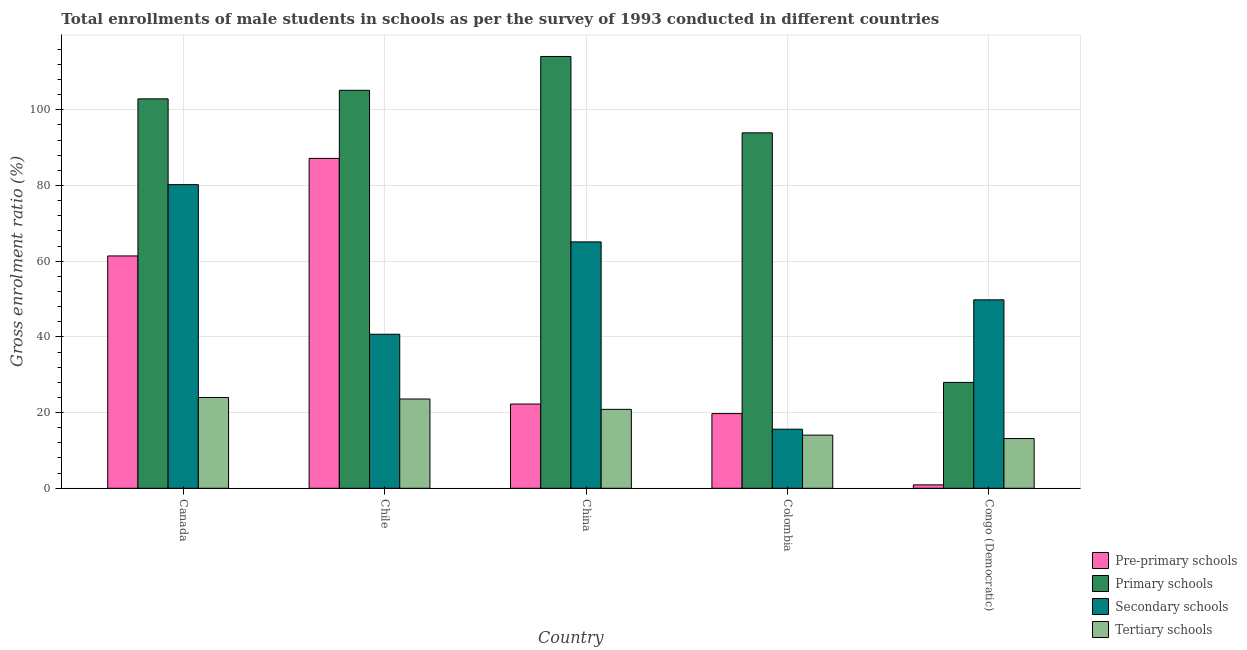How many different coloured bars are there?
Keep it short and to the point. 4. How many groups of bars are there?
Your answer should be compact. 5. Are the number of bars per tick equal to the number of legend labels?
Provide a succinct answer. Yes. Are the number of bars on each tick of the X-axis equal?
Offer a very short reply. Yes. How many bars are there on the 3rd tick from the right?
Provide a short and direct response. 4. What is the gross enrolment ratio(male) in pre-primary schools in Colombia?
Your answer should be very brief. 19.73. Across all countries, what is the maximum gross enrolment ratio(male) in primary schools?
Provide a short and direct response. 114.07. Across all countries, what is the minimum gross enrolment ratio(male) in primary schools?
Provide a succinct answer. 27.97. In which country was the gross enrolment ratio(male) in tertiary schools maximum?
Offer a terse response. Canada. In which country was the gross enrolment ratio(male) in secondary schools minimum?
Give a very brief answer. Colombia. What is the total gross enrolment ratio(male) in secondary schools in the graph?
Ensure brevity in your answer.  251.39. What is the difference between the gross enrolment ratio(male) in pre-primary schools in Colombia and that in Congo (Democratic)?
Provide a short and direct response. 18.83. What is the difference between the gross enrolment ratio(male) in tertiary schools in Canada and the gross enrolment ratio(male) in primary schools in Colombia?
Offer a terse response. -69.91. What is the average gross enrolment ratio(male) in tertiary schools per country?
Your response must be concise. 19.12. What is the difference between the gross enrolment ratio(male) in secondary schools and gross enrolment ratio(male) in tertiary schools in Chile?
Keep it short and to the point. 17.11. In how many countries, is the gross enrolment ratio(male) in secondary schools greater than 84 %?
Your response must be concise. 0. What is the ratio of the gross enrolment ratio(male) in pre-primary schools in China to that in Colombia?
Offer a very short reply. 1.13. Is the gross enrolment ratio(male) in secondary schools in Canada less than that in Congo (Democratic)?
Your answer should be compact. No. What is the difference between the highest and the second highest gross enrolment ratio(male) in primary schools?
Your answer should be very brief. 8.94. What is the difference between the highest and the lowest gross enrolment ratio(male) in pre-primary schools?
Your response must be concise. 86.24. What does the 4th bar from the left in Congo (Democratic) represents?
Offer a terse response. Tertiary schools. What does the 4th bar from the right in Colombia represents?
Ensure brevity in your answer.  Pre-primary schools. Is it the case that in every country, the sum of the gross enrolment ratio(male) in pre-primary schools and gross enrolment ratio(male) in primary schools is greater than the gross enrolment ratio(male) in secondary schools?
Keep it short and to the point. No. How many countries are there in the graph?
Provide a succinct answer. 5. What is the difference between two consecutive major ticks on the Y-axis?
Offer a terse response. 20. Does the graph contain any zero values?
Make the answer very short. No. What is the title of the graph?
Your response must be concise. Total enrollments of male students in schools as per the survey of 1993 conducted in different countries. Does "Rule based governance" appear as one of the legend labels in the graph?
Keep it short and to the point. No. What is the label or title of the X-axis?
Offer a very short reply. Country. What is the label or title of the Y-axis?
Give a very brief answer. Gross enrolment ratio (%). What is the Gross enrolment ratio (%) of Pre-primary schools in Canada?
Provide a succinct answer. 61.38. What is the Gross enrolment ratio (%) in Primary schools in Canada?
Offer a terse response. 102.87. What is the Gross enrolment ratio (%) of Secondary schools in Canada?
Provide a succinct answer. 80.21. What is the Gross enrolment ratio (%) in Tertiary schools in Canada?
Give a very brief answer. 23.98. What is the Gross enrolment ratio (%) in Pre-primary schools in Chile?
Your answer should be very brief. 87.14. What is the Gross enrolment ratio (%) in Primary schools in Chile?
Give a very brief answer. 105.13. What is the Gross enrolment ratio (%) of Secondary schools in Chile?
Offer a terse response. 40.69. What is the Gross enrolment ratio (%) of Tertiary schools in Chile?
Ensure brevity in your answer.  23.58. What is the Gross enrolment ratio (%) of Pre-primary schools in China?
Your response must be concise. 22.25. What is the Gross enrolment ratio (%) in Primary schools in China?
Your answer should be compact. 114.07. What is the Gross enrolment ratio (%) of Secondary schools in China?
Your response must be concise. 65.09. What is the Gross enrolment ratio (%) of Tertiary schools in China?
Offer a terse response. 20.85. What is the Gross enrolment ratio (%) in Pre-primary schools in Colombia?
Offer a terse response. 19.73. What is the Gross enrolment ratio (%) in Primary schools in Colombia?
Your response must be concise. 93.9. What is the Gross enrolment ratio (%) of Secondary schools in Colombia?
Provide a short and direct response. 15.61. What is the Gross enrolment ratio (%) of Tertiary schools in Colombia?
Provide a short and direct response. 14.04. What is the Gross enrolment ratio (%) of Pre-primary schools in Congo (Democratic)?
Offer a very short reply. 0.9. What is the Gross enrolment ratio (%) of Primary schools in Congo (Democratic)?
Make the answer very short. 27.97. What is the Gross enrolment ratio (%) of Secondary schools in Congo (Democratic)?
Offer a very short reply. 49.79. What is the Gross enrolment ratio (%) in Tertiary schools in Congo (Democratic)?
Your answer should be compact. 13.14. Across all countries, what is the maximum Gross enrolment ratio (%) of Pre-primary schools?
Offer a very short reply. 87.14. Across all countries, what is the maximum Gross enrolment ratio (%) in Primary schools?
Your answer should be compact. 114.07. Across all countries, what is the maximum Gross enrolment ratio (%) of Secondary schools?
Offer a very short reply. 80.21. Across all countries, what is the maximum Gross enrolment ratio (%) in Tertiary schools?
Provide a short and direct response. 23.98. Across all countries, what is the minimum Gross enrolment ratio (%) of Pre-primary schools?
Provide a succinct answer. 0.9. Across all countries, what is the minimum Gross enrolment ratio (%) of Primary schools?
Provide a succinct answer. 27.97. Across all countries, what is the minimum Gross enrolment ratio (%) of Secondary schools?
Keep it short and to the point. 15.61. Across all countries, what is the minimum Gross enrolment ratio (%) in Tertiary schools?
Your answer should be compact. 13.14. What is the total Gross enrolment ratio (%) in Pre-primary schools in the graph?
Give a very brief answer. 191.4. What is the total Gross enrolment ratio (%) in Primary schools in the graph?
Offer a terse response. 443.94. What is the total Gross enrolment ratio (%) in Secondary schools in the graph?
Your response must be concise. 251.39. What is the total Gross enrolment ratio (%) of Tertiary schools in the graph?
Provide a short and direct response. 95.59. What is the difference between the Gross enrolment ratio (%) in Pre-primary schools in Canada and that in Chile?
Ensure brevity in your answer.  -25.77. What is the difference between the Gross enrolment ratio (%) of Primary schools in Canada and that in Chile?
Your answer should be compact. -2.26. What is the difference between the Gross enrolment ratio (%) of Secondary schools in Canada and that in Chile?
Your answer should be very brief. 39.52. What is the difference between the Gross enrolment ratio (%) in Tertiary schools in Canada and that in Chile?
Keep it short and to the point. 0.4. What is the difference between the Gross enrolment ratio (%) in Pre-primary schools in Canada and that in China?
Provide a succinct answer. 39.12. What is the difference between the Gross enrolment ratio (%) in Primary schools in Canada and that in China?
Provide a short and direct response. -11.2. What is the difference between the Gross enrolment ratio (%) of Secondary schools in Canada and that in China?
Offer a very short reply. 15.12. What is the difference between the Gross enrolment ratio (%) of Tertiary schools in Canada and that in China?
Make the answer very short. 3.13. What is the difference between the Gross enrolment ratio (%) of Pre-primary schools in Canada and that in Colombia?
Ensure brevity in your answer.  41.65. What is the difference between the Gross enrolment ratio (%) in Primary schools in Canada and that in Colombia?
Keep it short and to the point. 8.97. What is the difference between the Gross enrolment ratio (%) in Secondary schools in Canada and that in Colombia?
Make the answer very short. 64.6. What is the difference between the Gross enrolment ratio (%) of Tertiary schools in Canada and that in Colombia?
Ensure brevity in your answer.  9.94. What is the difference between the Gross enrolment ratio (%) in Pre-primary schools in Canada and that in Congo (Democratic)?
Ensure brevity in your answer.  60.48. What is the difference between the Gross enrolment ratio (%) of Primary schools in Canada and that in Congo (Democratic)?
Provide a succinct answer. 74.9. What is the difference between the Gross enrolment ratio (%) in Secondary schools in Canada and that in Congo (Democratic)?
Ensure brevity in your answer.  30.43. What is the difference between the Gross enrolment ratio (%) in Tertiary schools in Canada and that in Congo (Democratic)?
Make the answer very short. 10.84. What is the difference between the Gross enrolment ratio (%) in Pre-primary schools in Chile and that in China?
Your response must be concise. 64.89. What is the difference between the Gross enrolment ratio (%) in Primary schools in Chile and that in China?
Offer a terse response. -8.94. What is the difference between the Gross enrolment ratio (%) of Secondary schools in Chile and that in China?
Offer a very short reply. -24.4. What is the difference between the Gross enrolment ratio (%) of Tertiary schools in Chile and that in China?
Your answer should be compact. 2.73. What is the difference between the Gross enrolment ratio (%) of Pre-primary schools in Chile and that in Colombia?
Make the answer very short. 67.42. What is the difference between the Gross enrolment ratio (%) of Primary schools in Chile and that in Colombia?
Keep it short and to the point. 11.24. What is the difference between the Gross enrolment ratio (%) in Secondary schools in Chile and that in Colombia?
Give a very brief answer. 25.08. What is the difference between the Gross enrolment ratio (%) of Tertiary schools in Chile and that in Colombia?
Offer a very short reply. 9.54. What is the difference between the Gross enrolment ratio (%) of Pre-primary schools in Chile and that in Congo (Democratic)?
Provide a short and direct response. 86.24. What is the difference between the Gross enrolment ratio (%) of Primary schools in Chile and that in Congo (Democratic)?
Your answer should be very brief. 77.16. What is the difference between the Gross enrolment ratio (%) in Secondary schools in Chile and that in Congo (Democratic)?
Your answer should be compact. -9.09. What is the difference between the Gross enrolment ratio (%) in Tertiary schools in Chile and that in Congo (Democratic)?
Give a very brief answer. 10.44. What is the difference between the Gross enrolment ratio (%) in Pre-primary schools in China and that in Colombia?
Offer a very short reply. 2.53. What is the difference between the Gross enrolment ratio (%) of Primary schools in China and that in Colombia?
Offer a terse response. 20.17. What is the difference between the Gross enrolment ratio (%) of Secondary schools in China and that in Colombia?
Your response must be concise. 49.48. What is the difference between the Gross enrolment ratio (%) of Tertiary schools in China and that in Colombia?
Make the answer very short. 6.81. What is the difference between the Gross enrolment ratio (%) in Pre-primary schools in China and that in Congo (Democratic)?
Offer a very short reply. 21.35. What is the difference between the Gross enrolment ratio (%) of Primary schools in China and that in Congo (Democratic)?
Provide a short and direct response. 86.1. What is the difference between the Gross enrolment ratio (%) of Secondary schools in China and that in Congo (Democratic)?
Keep it short and to the point. 15.31. What is the difference between the Gross enrolment ratio (%) in Tertiary schools in China and that in Congo (Democratic)?
Offer a very short reply. 7.71. What is the difference between the Gross enrolment ratio (%) of Pre-primary schools in Colombia and that in Congo (Democratic)?
Ensure brevity in your answer.  18.83. What is the difference between the Gross enrolment ratio (%) in Primary schools in Colombia and that in Congo (Democratic)?
Offer a terse response. 65.93. What is the difference between the Gross enrolment ratio (%) of Secondary schools in Colombia and that in Congo (Democratic)?
Offer a terse response. -34.18. What is the difference between the Gross enrolment ratio (%) in Tertiary schools in Colombia and that in Congo (Democratic)?
Give a very brief answer. 0.9. What is the difference between the Gross enrolment ratio (%) of Pre-primary schools in Canada and the Gross enrolment ratio (%) of Primary schools in Chile?
Your answer should be very brief. -43.76. What is the difference between the Gross enrolment ratio (%) of Pre-primary schools in Canada and the Gross enrolment ratio (%) of Secondary schools in Chile?
Offer a very short reply. 20.68. What is the difference between the Gross enrolment ratio (%) in Pre-primary schools in Canada and the Gross enrolment ratio (%) in Tertiary schools in Chile?
Keep it short and to the point. 37.79. What is the difference between the Gross enrolment ratio (%) of Primary schools in Canada and the Gross enrolment ratio (%) of Secondary schools in Chile?
Offer a terse response. 62.18. What is the difference between the Gross enrolment ratio (%) of Primary schools in Canada and the Gross enrolment ratio (%) of Tertiary schools in Chile?
Your answer should be very brief. 79.29. What is the difference between the Gross enrolment ratio (%) in Secondary schools in Canada and the Gross enrolment ratio (%) in Tertiary schools in Chile?
Give a very brief answer. 56.63. What is the difference between the Gross enrolment ratio (%) in Pre-primary schools in Canada and the Gross enrolment ratio (%) in Primary schools in China?
Your response must be concise. -52.7. What is the difference between the Gross enrolment ratio (%) in Pre-primary schools in Canada and the Gross enrolment ratio (%) in Secondary schools in China?
Your response must be concise. -3.72. What is the difference between the Gross enrolment ratio (%) in Pre-primary schools in Canada and the Gross enrolment ratio (%) in Tertiary schools in China?
Your answer should be very brief. 40.52. What is the difference between the Gross enrolment ratio (%) in Primary schools in Canada and the Gross enrolment ratio (%) in Secondary schools in China?
Your response must be concise. 37.78. What is the difference between the Gross enrolment ratio (%) in Primary schools in Canada and the Gross enrolment ratio (%) in Tertiary schools in China?
Your answer should be compact. 82.02. What is the difference between the Gross enrolment ratio (%) in Secondary schools in Canada and the Gross enrolment ratio (%) in Tertiary schools in China?
Your answer should be very brief. 59.36. What is the difference between the Gross enrolment ratio (%) of Pre-primary schools in Canada and the Gross enrolment ratio (%) of Primary schools in Colombia?
Provide a short and direct response. -32.52. What is the difference between the Gross enrolment ratio (%) of Pre-primary schools in Canada and the Gross enrolment ratio (%) of Secondary schools in Colombia?
Provide a succinct answer. 45.77. What is the difference between the Gross enrolment ratio (%) in Pre-primary schools in Canada and the Gross enrolment ratio (%) in Tertiary schools in Colombia?
Your response must be concise. 47.34. What is the difference between the Gross enrolment ratio (%) of Primary schools in Canada and the Gross enrolment ratio (%) of Secondary schools in Colombia?
Make the answer very short. 87.26. What is the difference between the Gross enrolment ratio (%) in Primary schools in Canada and the Gross enrolment ratio (%) in Tertiary schools in Colombia?
Provide a succinct answer. 88.83. What is the difference between the Gross enrolment ratio (%) in Secondary schools in Canada and the Gross enrolment ratio (%) in Tertiary schools in Colombia?
Provide a short and direct response. 66.17. What is the difference between the Gross enrolment ratio (%) of Pre-primary schools in Canada and the Gross enrolment ratio (%) of Primary schools in Congo (Democratic)?
Provide a short and direct response. 33.41. What is the difference between the Gross enrolment ratio (%) of Pre-primary schools in Canada and the Gross enrolment ratio (%) of Secondary schools in Congo (Democratic)?
Provide a short and direct response. 11.59. What is the difference between the Gross enrolment ratio (%) of Pre-primary schools in Canada and the Gross enrolment ratio (%) of Tertiary schools in Congo (Democratic)?
Offer a terse response. 48.24. What is the difference between the Gross enrolment ratio (%) of Primary schools in Canada and the Gross enrolment ratio (%) of Secondary schools in Congo (Democratic)?
Provide a short and direct response. 53.09. What is the difference between the Gross enrolment ratio (%) of Primary schools in Canada and the Gross enrolment ratio (%) of Tertiary schools in Congo (Democratic)?
Ensure brevity in your answer.  89.73. What is the difference between the Gross enrolment ratio (%) of Secondary schools in Canada and the Gross enrolment ratio (%) of Tertiary schools in Congo (Democratic)?
Provide a succinct answer. 67.07. What is the difference between the Gross enrolment ratio (%) in Pre-primary schools in Chile and the Gross enrolment ratio (%) in Primary schools in China?
Provide a succinct answer. -26.93. What is the difference between the Gross enrolment ratio (%) of Pre-primary schools in Chile and the Gross enrolment ratio (%) of Secondary schools in China?
Give a very brief answer. 22.05. What is the difference between the Gross enrolment ratio (%) in Pre-primary schools in Chile and the Gross enrolment ratio (%) in Tertiary schools in China?
Provide a short and direct response. 66.29. What is the difference between the Gross enrolment ratio (%) in Primary schools in Chile and the Gross enrolment ratio (%) in Secondary schools in China?
Make the answer very short. 40.04. What is the difference between the Gross enrolment ratio (%) of Primary schools in Chile and the Gross enrolment ratio (%) of Tertiary schools in China?
Ensure brevity in your answer.  84.28. What is the difference between the Gross enrolment ratio (%) of Secondary schools in Chile and the Gross enrolment ratio (%) of Tertiary schools in China?
Offer a terse response. 19.84. What is the difference between the Gross enrolment ratio (%) in Pre-primary schools in Chile and the Gross enrolment ratio (%) in Primary schools in Colombia?
Ensure brevity in your answer.  -6.75. What is the difference between the Gross enrolment ratio (%) of Pre-primary schools in Chile and the Gross enrolment ratio (%) of Secondary schools in Colombia?
Provide a succinct answer. 71.53. What is the difference between the Gross enrolment ratio (%) of Pre-primary schools in Chile and the Gross enrolment ratio (%) of Tertiary schools in Colombia?
Your response must be concise. 73.11. What is the difference between the Gross enrolment ratio (%) of Primary schools in Chile and the Gross enrolment ratio (%) of Secondary schools in Colombia?
Make the answer very short. 89.52. What is the difference between the Gross enrolment ratio (%) in Primary schools in Chile and the Gross enrolment ratio (%) in Tertiary schools in Colombia?
Offer a very short reply. 91.09. What is the difference between the Gross enrolment ratio (%) of Secondary schools in Chile and the Gross enrolment ratio (%) of Tertiary schools in Colombia?
Give a very brief answer. 26.65. What is the difference between the Gross enrolment ratio (%) in Pre-primary schools in Chile and the Gross enrolment ratio (%) in Primary schools in Congo (Democratic)?
Your answer should be very brief. 59.17. What is the difference between the Gross enrolment ratio (%) of Pre-primary schools in Chile and the Gross enrolment ratio (%) of Secondary schools in Congo (Democratic)?
Provide a succinct answer. 37.36. What is the difference between the Gross enrolment ratio (%) of Pre-primary schools in Chile and the Gross enrolment ratio (%) of Tertiary schools in Congo (Democratic)?
Your answer should be very brief. 74.01. What is the difference between the Gross enrolment ratio (%) of Primary schools in Chile and the Gross enrolment ratio (%) of Secondary schools in Congo (Democratic)?
Keep it short and to the point. 55.35. What is the difference between the Gross enrolment ratio (%) of Primary schools in Chile and the Gross enrolment ratio (%) of Tertiary schools in Congo (Democratic)?
Your answer should be compact. 91.99. What is the difference between the Gross enrolment ratio (%) of Secondary schools in Chile and the Gross enrolment ratio (%) of Tertiary schools in Congo (Democratic)?
Offer a very short reply. 27.55. What is the difference between the Gross enrolment ratio (%) of Pre-primary schools in China and the Gross enrolment ratio (%) of Primary schools in Colombia?
Make the answer very short. -71.64. What is the difference between the Gross enrolment ratio (%) of Pre-primary schools in China and the Gross enrolment ratio (%) of Secondary schools in Colombia?
Keep it short and to the point. 6.64. What is the difference between the Gross enrolment ratio (%) in Pre-primary schools in China and the Gross enrolment ratio (%) in Tertiary schools in Colombia?
Offer a terse response. 8.22. What is the difference between the Gross enrolment ratio (%) of Primary schools in China and the Gross enrolment ratio (%) of Secondary schools in Colombia?
Offer a terse response. 98.46. What is the difference between the Gross enrolment ratio (%) in Primary schools in China and the Gross enrolment ratio (%) in Tertiary schools in Colombia?
Ensure brevity in your answer.  100.03. What is the difference between the Gross enrolment ratio (%) of Secondary schools in China and the Gross enrolment ratio (%) of Tertiary schools in Colombia?
Make the answer very short. 51.05. What is the difference between the Gross enrolment ratio (%) of Pre-primary schools in China and the Gross enrolment ratio (%) of Primary schools in Congo (Democratic)?
Your answer should be compact. -5.72. What is the difference between the Gross enrolment ratio (%) in Pre-primary schools in China and the Gross enrolment ratio (%) in Secondary schools in Congo (Democratic)?
Offer a terse response. -27.53. What is the difference between the Gross enrolment ratio (%) in Pre-primary schools in China and the Gross enrolment ratio (%) in Tertiary schools in Congo (Democratic)?
Provide a short and direct response. 9.12. What is the difference between the Gross enrolment ratio (%) in Primary schools in China and the Gross enrolment ratio (%) in Secondary schools in Congo (Democratic)?
Your answer should be compact. 64.29. What is the difference between the Gross enrolment ratio (%) of Primary schools in China and the Gross enrolment ratio (%) of Tertiary schools in Congo (Democratic)?
Ensure brevity in your answer.  100.93. What is the difference between the Gross enrolment ratio (%) of Secondary schools in China and the Gross enrolment ratio (%) of Tertiary schools in Congo (Democratic)?
Ensure brevity in your answer.  51.95. What is the difference between the Gross enrolment ratio (%) of Pre-primary schools in Colombia and the Gross enrolment ratio (%) of Primary schools in Congo (Democratic)?
Your answer should be compact. -8.24. What is the difference between the Gross enrolment ratio (%) of Pre-primary schools in Colombia and the Gross enrolment ratio (%) of Secondary schools in Congo (Democratic)?
Provide a succinct answer. -30.06. What is the difference between the Gross enrolment ratio (%) in Pre-primary schools in Colombia and the Gross enrolment ratio (%) in Tertiary schools in Congo (Democratic)?
Provide a succinct answer. 6.59. What is the difference between the Gross enrolment ratio (%) of Primary schools in Colombia and the Gross enrolment ratio (%) of Secondary schools in Congo (Democratic)?
Your answer should be very brief. 44.11. What is the difference between the Gross enrolment ratio (%) of Primary schools in Colombia and the Gross enrolment ratio (%) of Tertiary schools in Congo (Democratic)?
Your response must be concise. 80.76. What is the difference between the Gross enrolment ratio (%) in Secondary schools in Colombia and the Gross enrolment ratio (%) in Tertiary schools in Congo (Democratic)?
Ensure brevity in your answer.  2.47. What is the average Gross enrolment ratio (%) in Pre-primary schools per country?
Make the answer very short. 38.28. What is the average Gross enrolment ratio (%) of Primary schools per country?
Provide a succinct answer. 88.79. What is the average Gross enrolment ratio (%) in Secondary schools per country?
Your response must be concise. 50.28. What is the average Gross enrolment ratio (%) of Tertiary schools per country?
Provide a short and direct response. 19.12. What is the difference between the Gross enrolment ratio (%) of Pre-primary schools and Gross enrolment ratio (%) of Primary schools in Canada?
Provide a succinct answer. -41.5. What is the difference between the Gross enrolment ratio (%) in Pre-primary schools and Gross enrolment ratio (%) in Secondary schools in Canada?
Offer a very short reply. -18.84. What is the difference between the Gross enrolment ratio (%) in Pre-primary schools and Gross enrolment ratio (%) in Tertiary schools in Canada?
Keep it short and to the point. 37.39. What is the difference between the Gross enrolment ratio (%) in Primary schools and Gross enrolment ratio (%) in Secondary schools in Canada?
Give a very brief answer. 22.66. What is the difference between the Gross enrolment ratio (%) of Primary schools and Gross enrolment ratio (%) of Tertiary schools in Canada?
Your response must be concise. 78.89. What is the difference between the Gross enrolment ratio (%) in Secondary schools and Gross enrolment ratio (%) in Tertiary schools in Canada?
Offer a terse response. 56.23. What is the difference between the Gross enrolment ratio (%) of Pre-primary schools and Gross enrolment ratio (%) of Primary schools in Chile?
Make the answer very short. -17.99. What is the difference between the Gross enrolment ratio (%) of Pre-primary schools and Gross enrolment ratio (%) of Secondary schools in Chile?
Keep it short and to the point. 46.45. What is the difference between the Gross enrolment ratio (%) of Pre-primary schools and Gross enrolment ratio (%) of Tertiary schools in Chile?
Make the answer very short. 63.56. What is the difference between the Gross enrolment ratio (%) in Primary schools and Gross enrolment ratio (%) in Secondary schools in Chile?
Make the answer very short. 64.44. What is the difference between the Gross enrolment ratio (%) in Primary schools and Gross enrolment ratio (%) in Tertiary schools in Chile?
Offer a terse response. 81.55. What is the difference between the Gross enrolment ratio (%) of Secondary schools and Gross enrolment ratio (%) of Tertiary schools in Chile?
Your answer should be very brief. 17.11. What is the difference between the Gross enrolment ratio (%) of Pre-primary schools and Gross enrolment ratio (%) of Primary schools in China?
Offer a very short reply. -91.82. What is the difference between the Gross enrolment ratio (%) in Pre-primary schools and Gross enrolment ratio (%) in Secondary schools in China?
Keep it short and to the point. -42.84. What is the difference between the Gross enrolment ratio (%) of Pre-primary schools and Gross enrolment ratio (%) of Tertiary schools in China?
Offer a terse response. 1.4. What is the difference between the Gross enrolment ratio (%) of Primary schools and Gross enrolment ratio (%) of Secondary schools in China?
Give a very brief answer. 48.98. What is the difference between the Gross enrolment ratio (%) in Primary schools and Gross enrolment ratio (%) in Tertiary schools in China?
Keep it short and to the point. 93.22. What is the difference between the Gross enrolment ratio (%) of Secondary schools and Gross enrolment ratio (%) of Tertiary schools in China?
Keep it short and to the point. 44.24. What is the difference between the Gross enrolment ratio (%) of Pre-primary schools and Gross enrolment ratio (%) of Primary schools in Colombia?
Make the answer very short. -74.17. What is the difference between the Gross enrolment ratio (%) of Pre-primary schools and Gross enrolment ratio (%) of Secondary schools in Colombia?
Your response must be concise. 4.12. What is the difference between the Gross enrolment ratio (%) of Pre-primary schools and Gross enrolment ratio (%) of Tertiary schools in Colombia?
Offer a very short reply. 5.69. What is the difference between the Gross enrolment ratio (%) in Primary schools and Gross enrolment ratio (%) in Secondary schools in Colombia?
Offer a terse response. 78.29. What is the difference between the Gross enrolment ratio (%) in Primary schools and Gross enrolment ratio (%) in Tertiary schools in Colombia?
Keep it short and to the point. 79.86. What is the difference between the Gross enrolment ratio (%) of Secondary schools and Gross enrolment ratio (%) of Tertiary schools in Colombia?
Keep it short and to the point. 1.57. What is the difference between the Gross enrolment ratio (%) in Pre-primary schools and Gross enrolment ratio (%) in Primary schools in Congo (Democratic)?
Your answer should be compact. -27.07. What is the difference between the Gross enrolment ratio (%) in Pre-primary schools and Gross enrolment ratio (%) in Secondary schools in Congo (Democratic)?
Your response must be concise. -48.89. What is the difference between the Gross enrolment ratio (%) in Pre-primary schools and Gross enrolment ratio (%) in Tertiary schools in Congo (Democratic)?
Your answer should be compact. -12.24. What is the difference between the Gross enrolment ratio (%) in Primary schools and Gross enrolment ratio (%) in Secondary schools in Congo (Democratic)?
Provide a short and direct response. -21.82. What is the difference between the Gross enrolment ratio (%) of Primary schools and Gross enrolment ratio (%) of Tertiary schools in Congo (Democratic)?
Your answer should be compact. 14.83. What is the difference between the Gross enrolment ratio (%) in Secondary schools and Gross enrolment ratio (%) in Tertiary schools in Congo (Democratic)?
Offer a terse response. 36.65. What is the ratio of the Gross enrolment ratio (%) of Pre-primary schools in Canada to that in Chile?
Offer a terse response. 0.7. What is the ratio of the Gross enrolment ratio (%) in Primary schools in Canada to that in Chile?
Keep it short and to the point. 0.98. What is the ratio of the Gross enrolment ratio (%) in Secondary schools in Canada to that in Chile?
Provide a short and direct response. 1.97. What is the ratio of the Gross enrolment ratio (%) in Tertiary schools in Canada to that in Chile?
Make the answer very short. 1.02. What is the ratio of the Gross enrolment ratio (%) of Pre-primary schools in Canada to that in China?
Give a very brief answer. 2.76. What is the ratio of the Gross enrolment ratio (%) in Primary schools in Canada to that in China?
Offer a terse response. 0.9. What is the ratio of the Gross enrolment ratio (%) of Secondary schools in Canada to that in China?
Offer a very short reply. 1.23. What is the ratio of the Gross enrolment ratio (%) of Tertiary schools in Canada to that in China?
Your answer should be compact. 1.15. What is the ratio of the Gross enrolment ratio (%) of Pre-primary schools in Canada to that in Colombia?
Offer a terse response. 3.11. What is the ratio of the Gross enrolment ratio (%) of Primary schools in Canada to that in Colombia?
Provide a succinct answer. 1.1. What is the ratio of the Gross enrolment ratio (%) in Secondary schools in Canada to that in Colombia?
Make the answer very short. 5.14. What is the ratio of the Gross enrolment ratio (%) in Tertiary schools in Canada to that in Colombia?
Keep it short and to the point. 1.71. What is the ratio of the Gross enrolment ratio (%) of Pre-primary schools in Canada to that in Congo (Democratic)?
Your answer should be compact. 68.19. What is the ratio of the Gross enrolment ratio (%) in Primary schools in Canada to that in Congo (Democratic)?
Offer a very short reply. 3.68. What is the ratio of the Gross enrolment ratio (%) in Secondary schools in Canada to that in Congo (Democratic)?
Your answer should be compact. 1.61. What is the ratio of the Gross enrolment ratio (%) of Tertiary schools in Canada to that in Congo (Democratic)?
Ensure brevity in your answer.  1.83. What is the ratio of the Gross enrolment ratio (%) of Pre-primary schools in Chile to that in China?
Provide a short and direct response. 3.92. What is the ratio of the Gross enrolment ratio (%) in Primary schools in Chile to that in China?
Offer a terse response. 0.92. What is the ratio of the Gross enrolment ratio (%) of Secondary schools in Chile to that in China?
Your answer should be very brief. 0.63. What is the ratio of the Gross enrolment ratio (%) in Tertiary schools in Chile to that in China?
Your answer should be very brief. 1.13. What is the ratio of the Gross enrolment ratio (%) in Pre-primary schools in Chile to that in Colombia?
Your answer should be very brief. 4.42. What is the ratio of the Gross enrolment ratio (%) of Primary schools in Chile to that in Colombia?
Provide a short and direct response. 1.12. What is the ratio of the Gross enrolment ratio (%) in Secondary schools in Chile to that in Colombia?
Ensure brevity in your answer.  2.61. What is the ratio of the Gross enrolment ratio (%) in Tertiary schools in Chile to that in Colombia?
Make the answer very short. 1.68. What is the ratio of the Gross enrolment ratio (%) of Pre-primary schools in Chile to that in Congo (Democratic)?
Make the answer very short. 96.81. What is the ratio of the Gross enrolment ratio (%) of Primary schools in Chile to that in Congo (Democratic)?
Ensure brevity in your answer.  3.76. What is the ratio of the Gross enrolment ratio (%) in Secondary schools in Chile to that in Congo (Democratic)?
Make the answer very short. 0.82. What is the ratio of the Gross enrolment ratio (%) in Tertiary schools in Chile to that in Congo (Democratic)?
Ensure brevity in your answer.  1.79. What is the ratio of the Gross enrolment ratio (%) in Pre-primary schools in China to that in Colombia?
Keep it short and to the point. 1.13. What is the ratio of the Gross enrolment ratio (%) of Primary schools in China to that in Colombia?
Keep it short and to the point. 1.21. What is the ratio of the Gross enrolment ratio (%) of Secondary schools in China to that in Colombia?
Offer a very short reply. 4.17. What is the ratio of the Gross enrolment ratio (%) of Tertiary schools in China to that in Colombia?
Your response must be concise. 1.49. What is the ratio of the Gross enrolment ratio (%) in Pre-primary schools in China to that in Congo (Democratic)?
Offer a terse response. 24.72. What is the ratio of the Gross enrolment ratio (%) of Primary schools in China to that in Congo (Democratic)?
Keep it short and to the point. 4.08. What is the ratio of the Gross enrolment ratio (%) in Secondary schools in China to that in Congo (Democratic)?
Your answer should be very brief. 1.31. What is the ratio of the Gross enrolment ratio (%) of Tertiary schools in China to that in Congo (Democratic)?
Make the answer very short. 1.59. What is the ratio of the Gross enrolment ratio (%) of Pre-primary schools in Colombia to that in Congo (Democratic)?
Offer a very short reply. 21.91. What is the ratio of the Gross enrolment ratio (%) in Primary schools in Colombia to that in Congo (Democratic)?
Make the answer very short. 3.36. What is the ratio of the Gross enrolment ratio (%) in Secondary schools in Colombia to that in Congo (Democratic)?
Keep it short and to the point. 0.31. What is the ratio of the Gross enrolment ratio (%) in Tertiary schools in Colombia to that in Congo (Democratic)?
Your answer should be compact. 1.07. What is the difference between the highest and the second highest Gross enrolment ratio (%) in Pre-primary schools?
Give a very brief answer. 25.77. What is the difference between the highest and the second highest Gross enrolment ratio (%) in Primary schools?
Your response must be concise. 8.94. What is the difference between the highest and the second highest Gross enrolment ratio (%) of Secondary schools?
Ensure brevity in your answer.  15.12. What is the difference between the highest and the second highest Gross enrolment ratio (%) of Tertiary schools?
Your answer should be very brief. 0.4. What is the difference between the highest and the lowest Gross enrolment ratio (%) in Pre-primary schools?
Keep it short and to the point. 86.24. What is the difference between the highest and the lowest Gross enrolment ratio (%) of Primary schools?
Your response must be concise. 86.1. What is the difference between the highest and the lowest Gross enrolment ratio (%) of Secondary schools?
Make the answer very short. 64.6. What is the difference between the highest and the lowest Gross enrolment ratio (%) of Tertiary schools?
Offer a terse response. 10.84. 